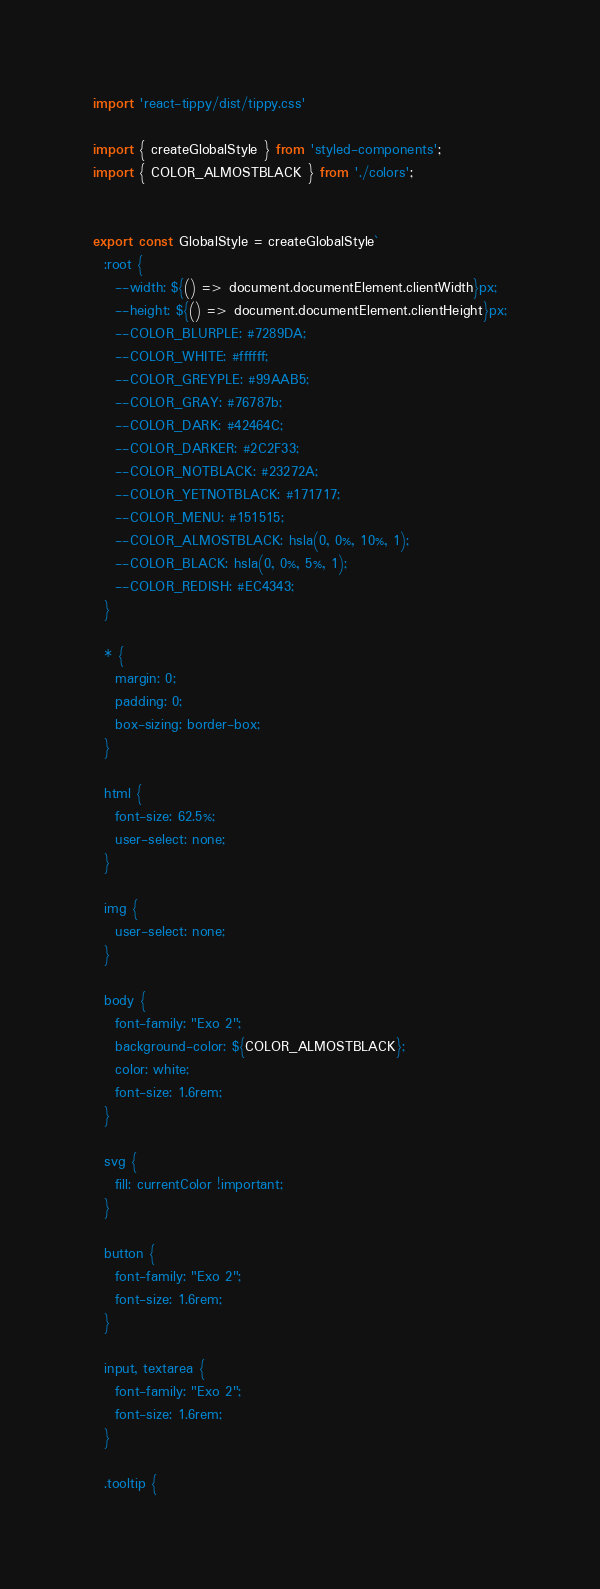<code> <loc_0><loc_0><loc_500><loc_500><_TypeScript_>
import 'react-tippy/dist/tippy.css'

import { createGlobalStyle } from 'styled-components';
import { COLOR_ALMOSTBLACK } from './colors';


export const GlobalStyle = createGlobalStyle`
  :root {
    --width: ${() => document.documentElement.clientWidth}px;
    --height: ${() => document.documentElement.clientHeight}px;
    --COLOR_BLURPLE: #7289DA;
    --COLOR_WHITE: #ffffff;
    --COLOR_GREYPLE: #99AAB5;
    --COLOR_GRAY: #76787b;
    --COLOR_DARK: #42464C;
    --COLOR_DARKER: #2C2F33;
    --COLOR_NOTBLACK: #23272A;
    --COLOR_YETNOTBLACK: #171717;
    --COLOR_MENU: #151515;
    --COLOR_ALMOSTBLACK: hsla(0, 0%, 10%, 1);
    --COLOR_BLACK: hsla(0, 0%, 5%, 1);
    --COLOR_REDISH: #EC4343;
  }

  * {
    margin: 0;
    padding: 0;
    box-sizing: border-box;
  }

  html {
    font-size: 62.5%;
    user-select: none;
  }
  
  img {
    user-select: none;
  }

  body {
    font-family: "Exo 2";
    background-color: ${COLOR_ALMOSTBLACK};
    color: white;
    font-size: 1.6rem;
  }

  svg {
    fill: currentColor !important;
  }

  button {
    font-family: "Exo 2";
    font-size: 1.6rem;
  }

  input, textarea {
    font-family: "Exo 2";
    font-size: 1.6rem;
  }

  .tooltip {</code> 